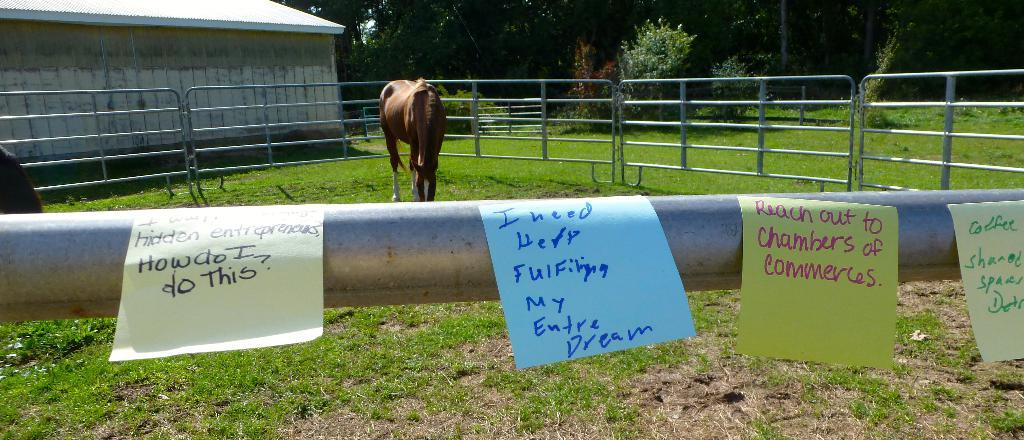What type of animal is on the ground in the image? The facts do not specify the type of animal, but there is an animal on the ground in the image. What kind of barrier can be seen in the image? There is a fence in the image. What type of structure is visible in the image? There is a shed in the image. What is the ground covered with in the image? Grass is present in the image. What type of decorations are in the image? There are posters in the image. What type of vegetation is visible in the image? Plants are visible in the image. What can be seen in the background of the image? There are trees in the background of the image. What time does the animal feel the most shame in the image? There is no indication of shame or time in the image; it simply shows an animal on the ground. What line is the animal standing on in the image? There is no line present in the image; the animal is on the ground. 